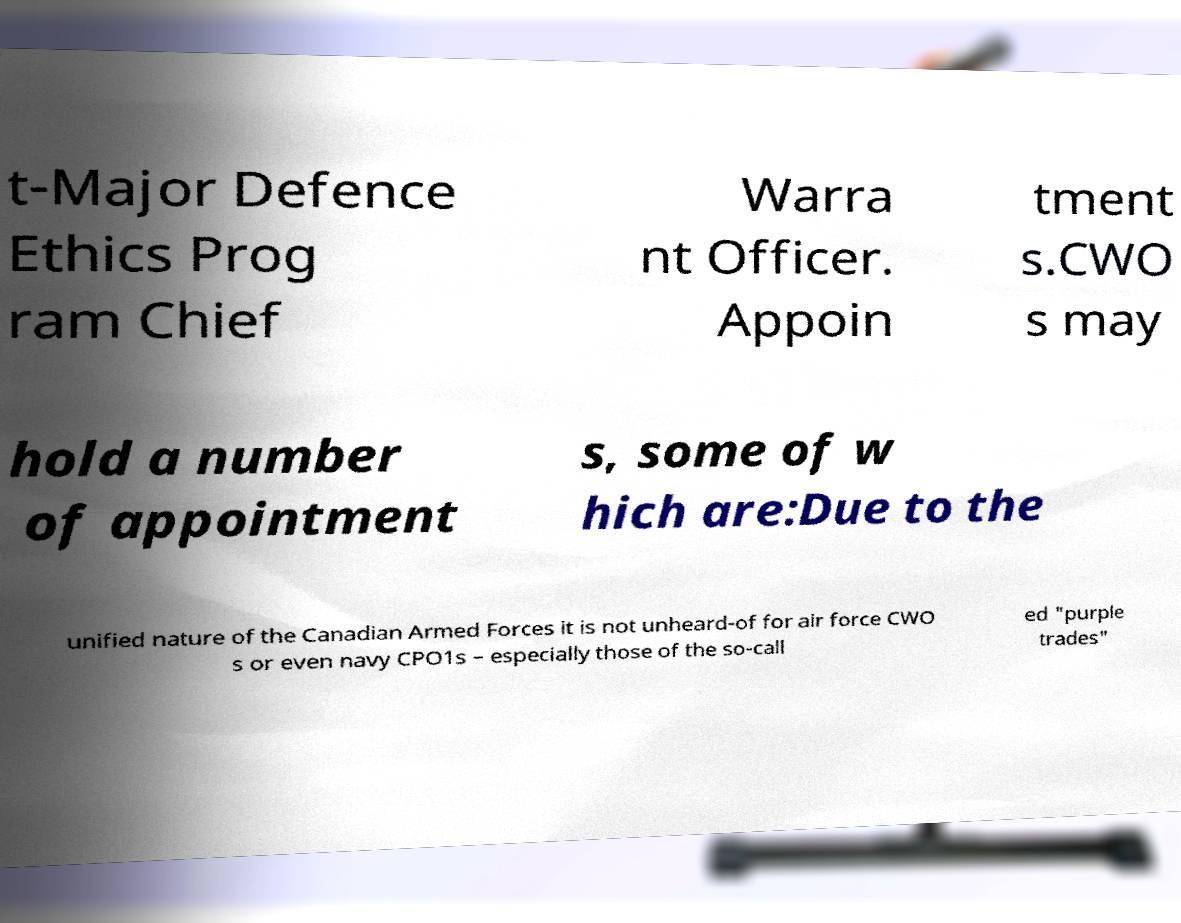There's text embedded in this image that I need extracted. Can you transcribe it verbatim? t-Major Defence Ethics Prog ram Chief Warra nt Officer. Appoin tment s.CWO s may hold a number of appointment s, some of w hich are:Due to the unified nature of the Canadian Armed Forces it is not unheard-of for air force CWO s or even navy CPO1s – especially those of the so-call ed "purple trades" 